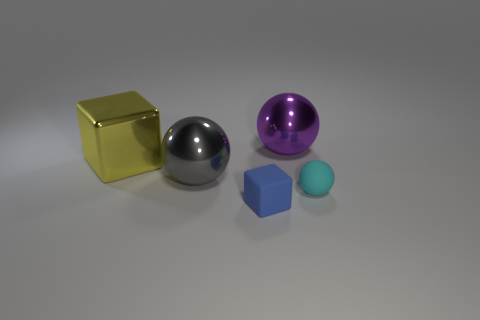Subtract all metallic spheres. How many spheres are left? 1 Add 3 cyan rubber things. How many objects exist? 8 Subtract all purple balls. How many balls are left? 2 Subtract all cubes. How many objects are left? 3 Add 1 gray objects. How many gray objects are left? 2 Add 5 small brown spheres. How many small brown spheres exist? 5 Subtract 1 blue cubes. How many objects are left? 4 Subtract 1 balls. How many balls are left? 2 Subtract all brown balls. Subtract all blue blocks. How many balls are left? 3 Subtract all purple spheres. How many purple cubes are left? 0 